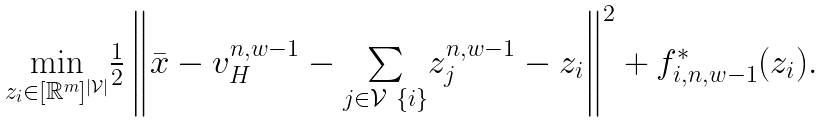<formula> <loc_0><loc_0><loc_500><loc_500>\begin{array} { c } \underset { { z } _ { i } \in [ \mathbb { R } ^ { m } ] ^ { | \mathcal { V } | } } { \min } \frac { 1 } { 2 } \left \| \bar { x } - { v } _ { H } ^ { n , w - 1 } - \underset { j \in \mathcal { V } \ \{ i \} } { \sum } { z } _ { j } ^ { n , w - 1 } - { z } _ { i } \right \| ^ { 2 } + f _ { i , n , w - 1 } ^ { * } ( { z } _ { i } ) . \end{array}</formula> 